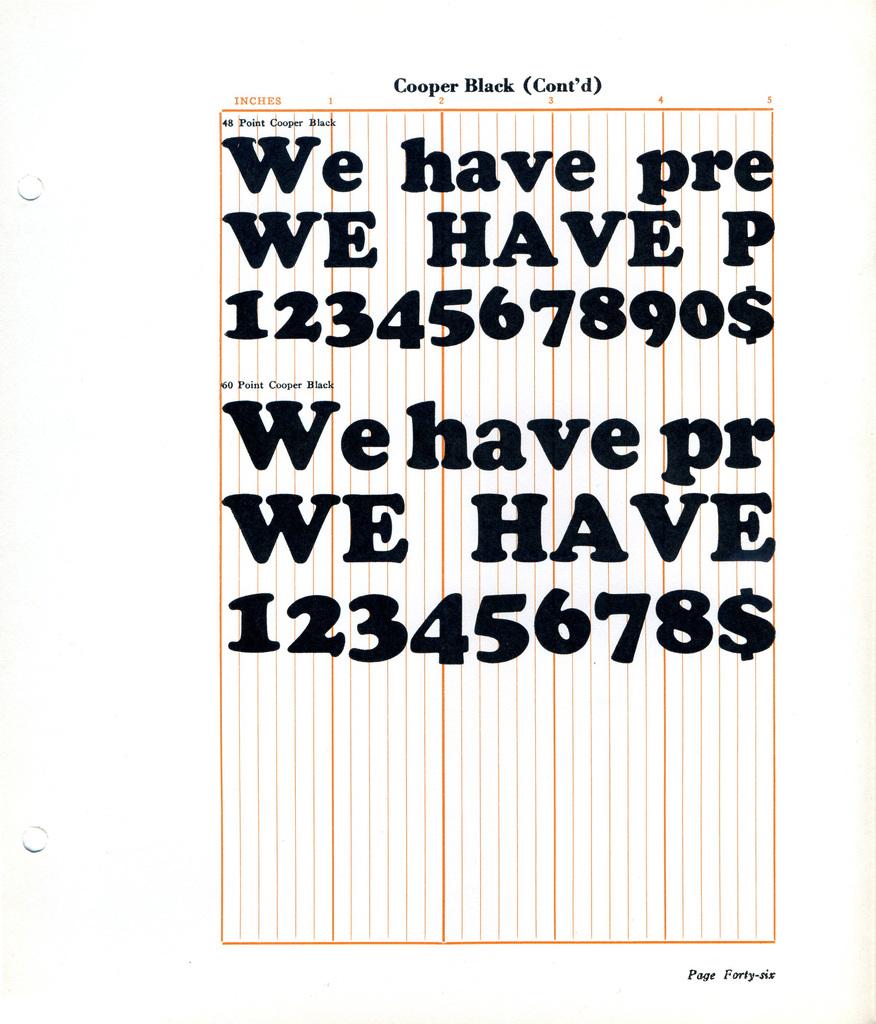What page is this?
Provide a short and direct response. 46. What is the second word on the page?
Keep it short and to the point. Have. 